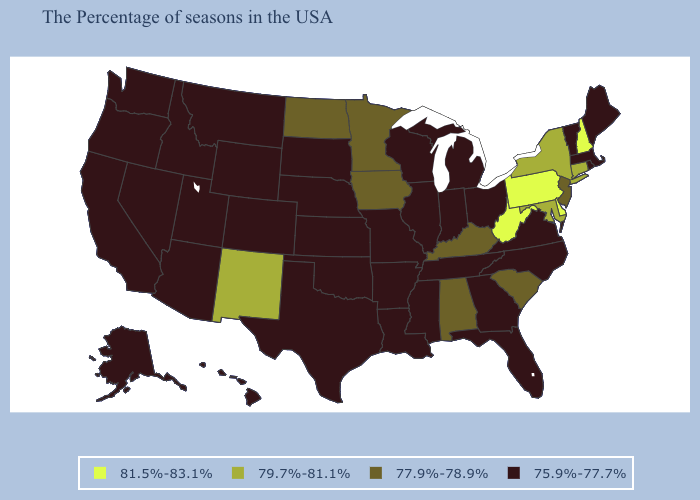What is the value of Indiana?
Quick response, please. 75.9%-77.7%. Does Rhode Island have the highest value in the Northeast?
Be succinct. No. How many symbols are there in the legend?
Short answer required. 4. What is the value of Wyoming?
Give a very brief answer. 75.9%-77.7%. Does Delaware have the same value as West Virginia?
Answer briefly. Yes. What is the value of California?
Short answer required. 75.9%-77.7%. Does Delaware have the highest value in the USA?
Answer briefly. Yes. Among the states that border Illinois , which have the highest value?
Give a very brief answer. Kentucky, Iowa. Does New Hampshire have the highest value in the Northeast?
Concise answer only. Yes. What is the value of Ohio?
Short answer required. 75.9%-77.7%. What is the lowest value in states that border Michigan?
Answer briefly. 75.9%-77.7%. What is the highest value in states that border Nevada?
Be succinct. 75.9%-77.7%. Which states have the lowest value in the Northeast?
Be succinct. Maine, Massachusetts, Rhode Island, Vermont. What is the value of Georgia?
Keep it brief. 75.9%-77.7%. Does Ohio have a lower value than Delaware?
Concise answer only. Yes. 